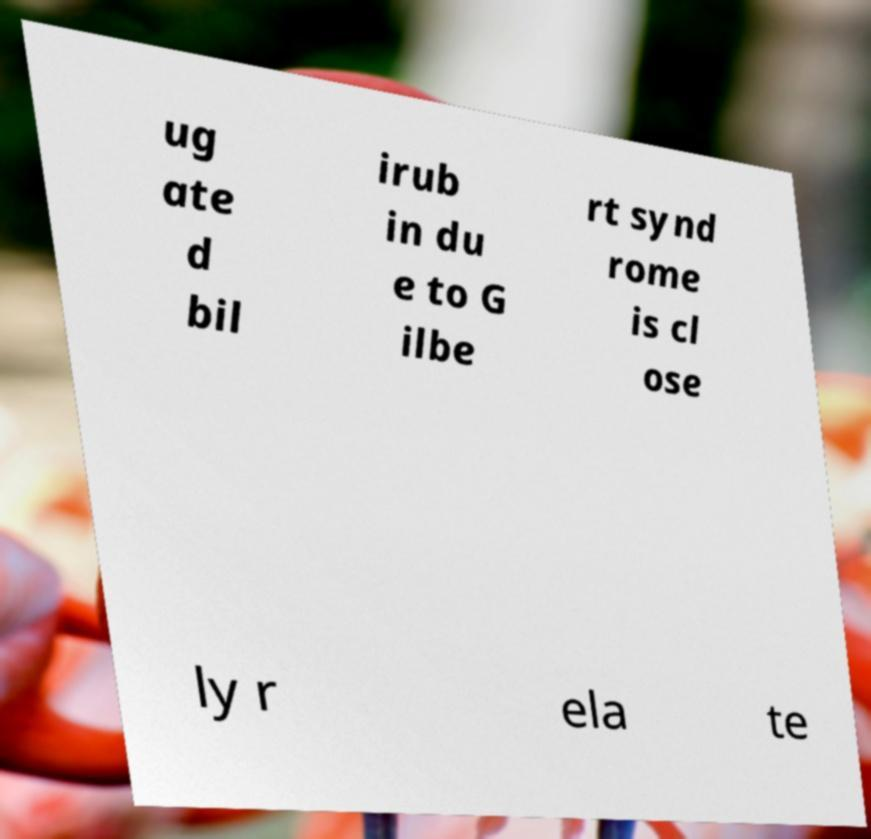Please identify and transcribe the text found in this image. ug ate d bil irub in du e to G ilbe rt synd rome is cl ose ly r ela te 